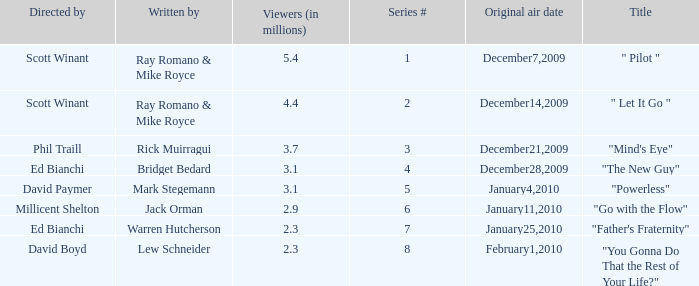What is the episode number of  "you gonna do that the rest of your life?" 8.0. 